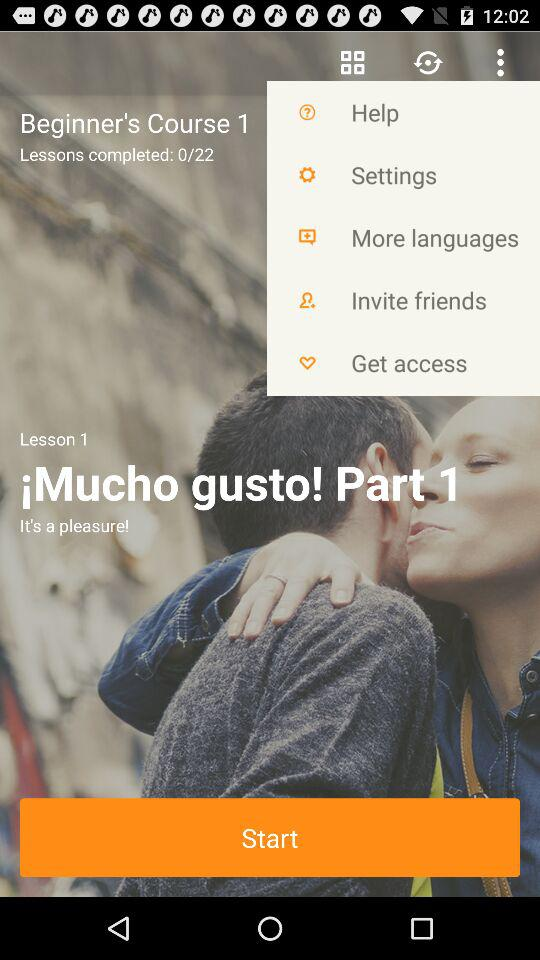How many lessons have you completed?
Answer the question using a single word or phrase. 0 